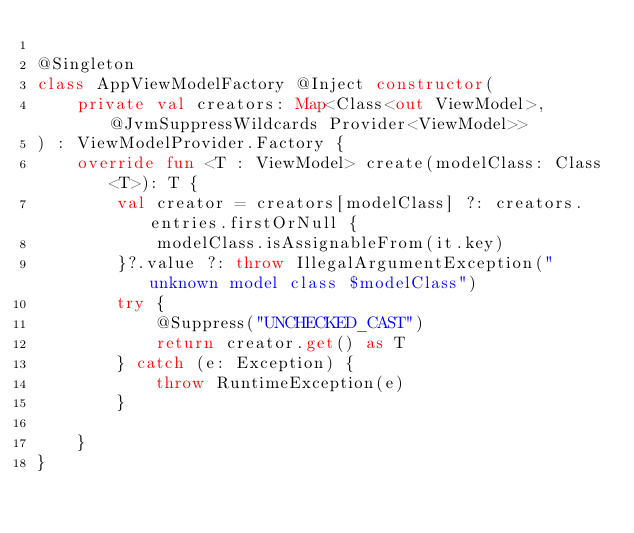<code> <loc_0><loc_0><loc_500><loc_500><_Kotlin_>
@Singleton
class AppViewModelFactory @Inject constructor(
    private val creators: Map<Class<out ViewModel>, @JvmSuppressWildcards Provider<ViewModel>>
) : ViewModelProvider.Factory {
    override fun <T : ViewModel> create(modelClass: Class<T>): T {
        val creator = creators[modelClass] ?: creators.entries.firstOrNull {
            modelClass.isAssignableFrom(it.key)
        }?.value ?: throw IllegalArgumentException("unknown model class $modelClass")
        try {
            @Suppress("UNCHECKED_CAST")
            return creator.get() as T
        } catch (e: Exception) {
            throw RuntimeException(e)
        }

    }
}
</code> 